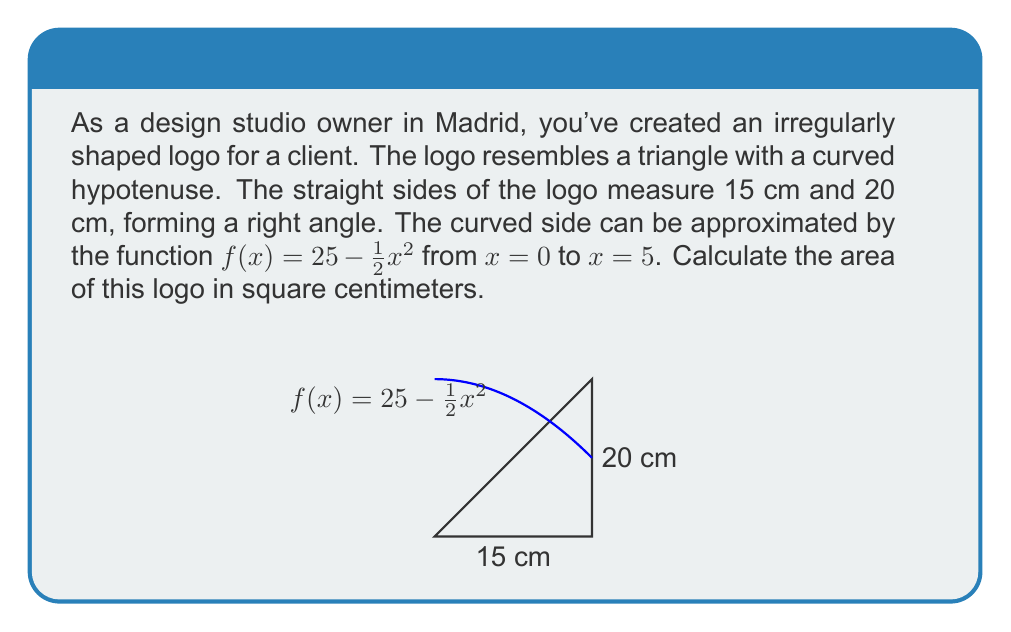Provide a solution to this math problem. To find the area of this irregularly shaped logo, we need to:

1) Calculate the area of the right triangle formed by the straight sides.
2) Calculate the area under the curve.
3) Subtract the area under the curve from the area of the triangle.

Step 1: Area of the right triangle
$$A_{triangle} = \frac{1}{2} \cdot base \cdot height = \frac{1}{2} \cdot 15 \cdot 20 = 150 \text{ cm}^2$$

Step 2: Area under the curve
We need to integrate the function $f(x) = 25 - \frac{1}{2}x^2$ from 0 to 5:

$$\begin{align}
A_{curve} &= \int_0^5 (25 - \frac{1}{2}x^2) dx \\
&= \left[25x - \frac{1}{6}x^3\right]_0^5 \\
&= (125 - \frac{125}{6}) - (0 - 0) \\
&= 125 - 20.8333... \\
&= 104.1667... \text{ cm}^2
\end{align}$$

Step 3: Area of the logo
$$\begin{align}
A_{logo} &= A_{triangle} - A_{curve} \\
&= 150 - 104.1667... \\
&= 45.8333... \text{ cm}^2
\end{align}$$
Answer: $45.83 \text{ cm}^2$ (rounded to 2 decimal places) 